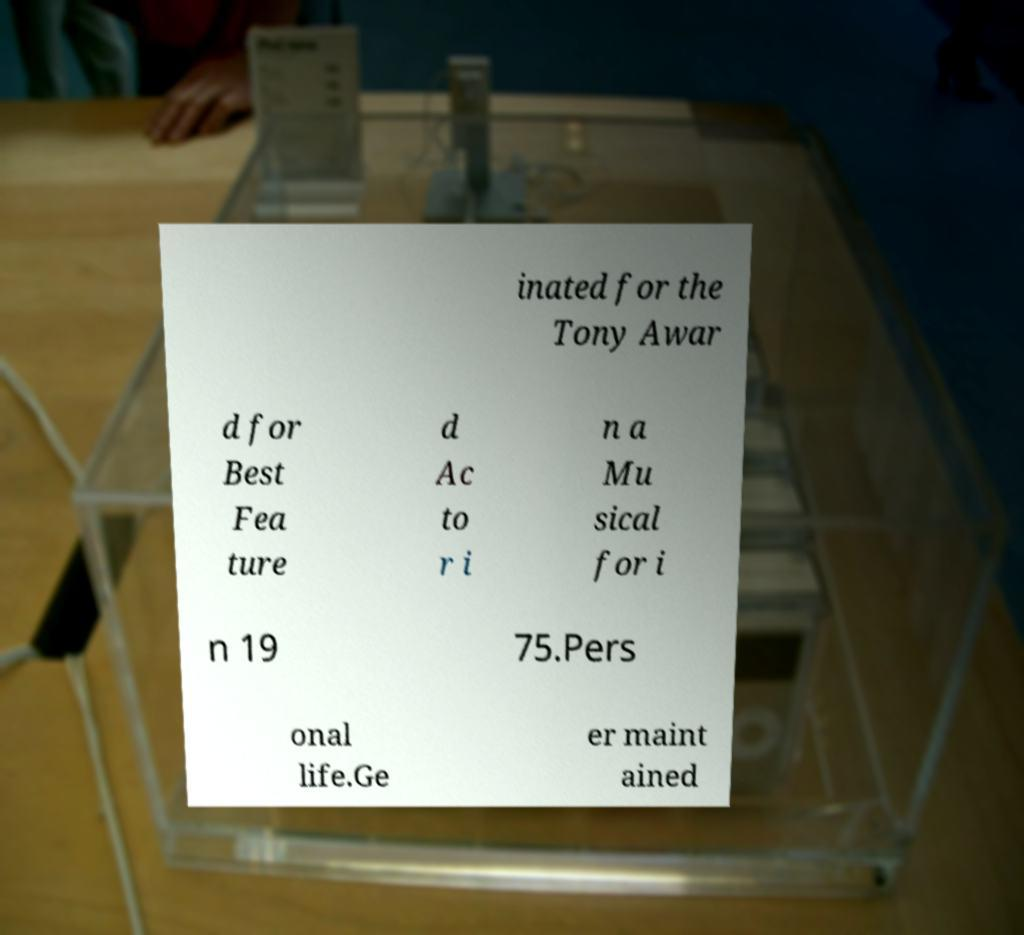Please read and relay the text visible in this image. What does it say? inated for the Tony Awar d for Best Fea ture d Ac to r i n a Mu sical for i n 19 75.Pers onal life.Ge er maint ained 